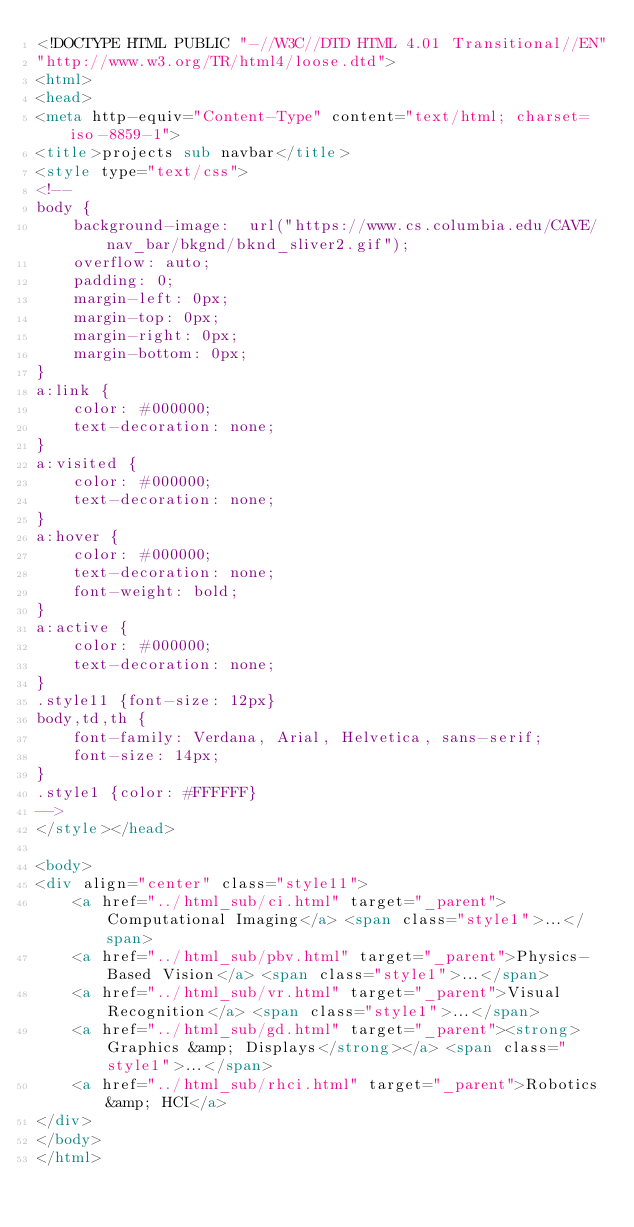Convert code to text. <code><loc_0><loc_0><loc_500><loc_500><_HTML_><!DOCTYPE HTML PUBLIC "-//W3C//DTD HTML 4.01 Transitional//EN"
"http://www.w3.org/TR/html4/loose.dtd">
<html>
<head>
<meta http-equiv="Content-Type" content="text/html; charset=iso-8859-1">
<title>projects sub navbar</title>
<style type="text/css">
<!--
body {
	background-image:  url("https://www.cs.columbia.edu/CAVE/nav_bar/bkgnd/bknd_sliver2.gif");
	overflow: auto;
	padding: 0;
	margin-left: 0px;
	margin-top: 0px;
	margin-right: 0px;
	margin-bottom: 0px;
}
a:link {
	color: #000000;
	text-decoration: none;
}
a:visited {
	color: #000000;
	text-decoration: none;
}
a:hover {
	color: #000000;
	text-decoration: none;
	font-weight: bold;
}
a:active {
	color: #000000;
	text-decoration: none;
}
.style11 {font-size: 12px}
body,td,th {
	font-family: Verdana, Arial, Helvetica, sans-serif;
	font-size: 14px;
}
.style1 {color: #FFFFFF}
-->
</style></head>

<body>
<div align="center" class="style11">
	<a href="../html_sub/ci.html" target="_parent">Computational Imaging</a> <span class="style1">...</span> 
    <a href="../html_sub/pbv.html" target="_parent">Physics-Based Vision</a> <span class="style1">...</span> 
    <a href="../html_sub/vr.html" target="_parent">Visual Recognition</a> <span class="style1">...</span> 
    <a href="../html_sub/gd.html" target="_parent"><strong>Graphics &amp; Displays</strong></a> <span class="style1">...</span> 
    <a href="../html_sub/rhci.html" target="_parent">Robotics &amp; HCI</a>
</div>
</body>
</html>
</code> 